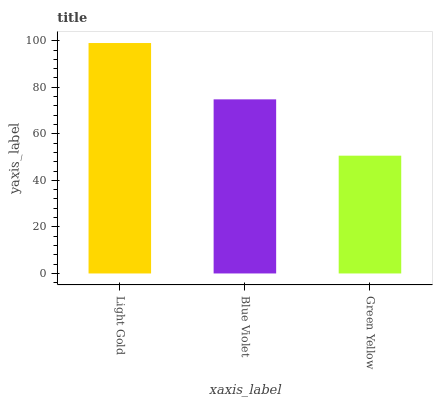Is Blue Violet the minimum?
Answer yes or no. No. Is Blue Violet the maximum?
Answer yes or no. No. Is Light Gold greater than Blue Violet?
Answer yes or no. Yes. Is Blue Violet less than Light Gold?
Answer yes or no. Yes. Is Blue Violet greater than Light Gold?
Answer yes or no. No. Is Light Gold less than Blue Violet?
Answer yes or no. No. Is Blue Violet the high median?
Answer yes or no. Yes. Is Blue Violet the low median?
Answer yes or no. Yes. Is Green Yellow the high median?
Answer yes or no. No. Is Light Gold the low median?
Answer yes or no. No. 